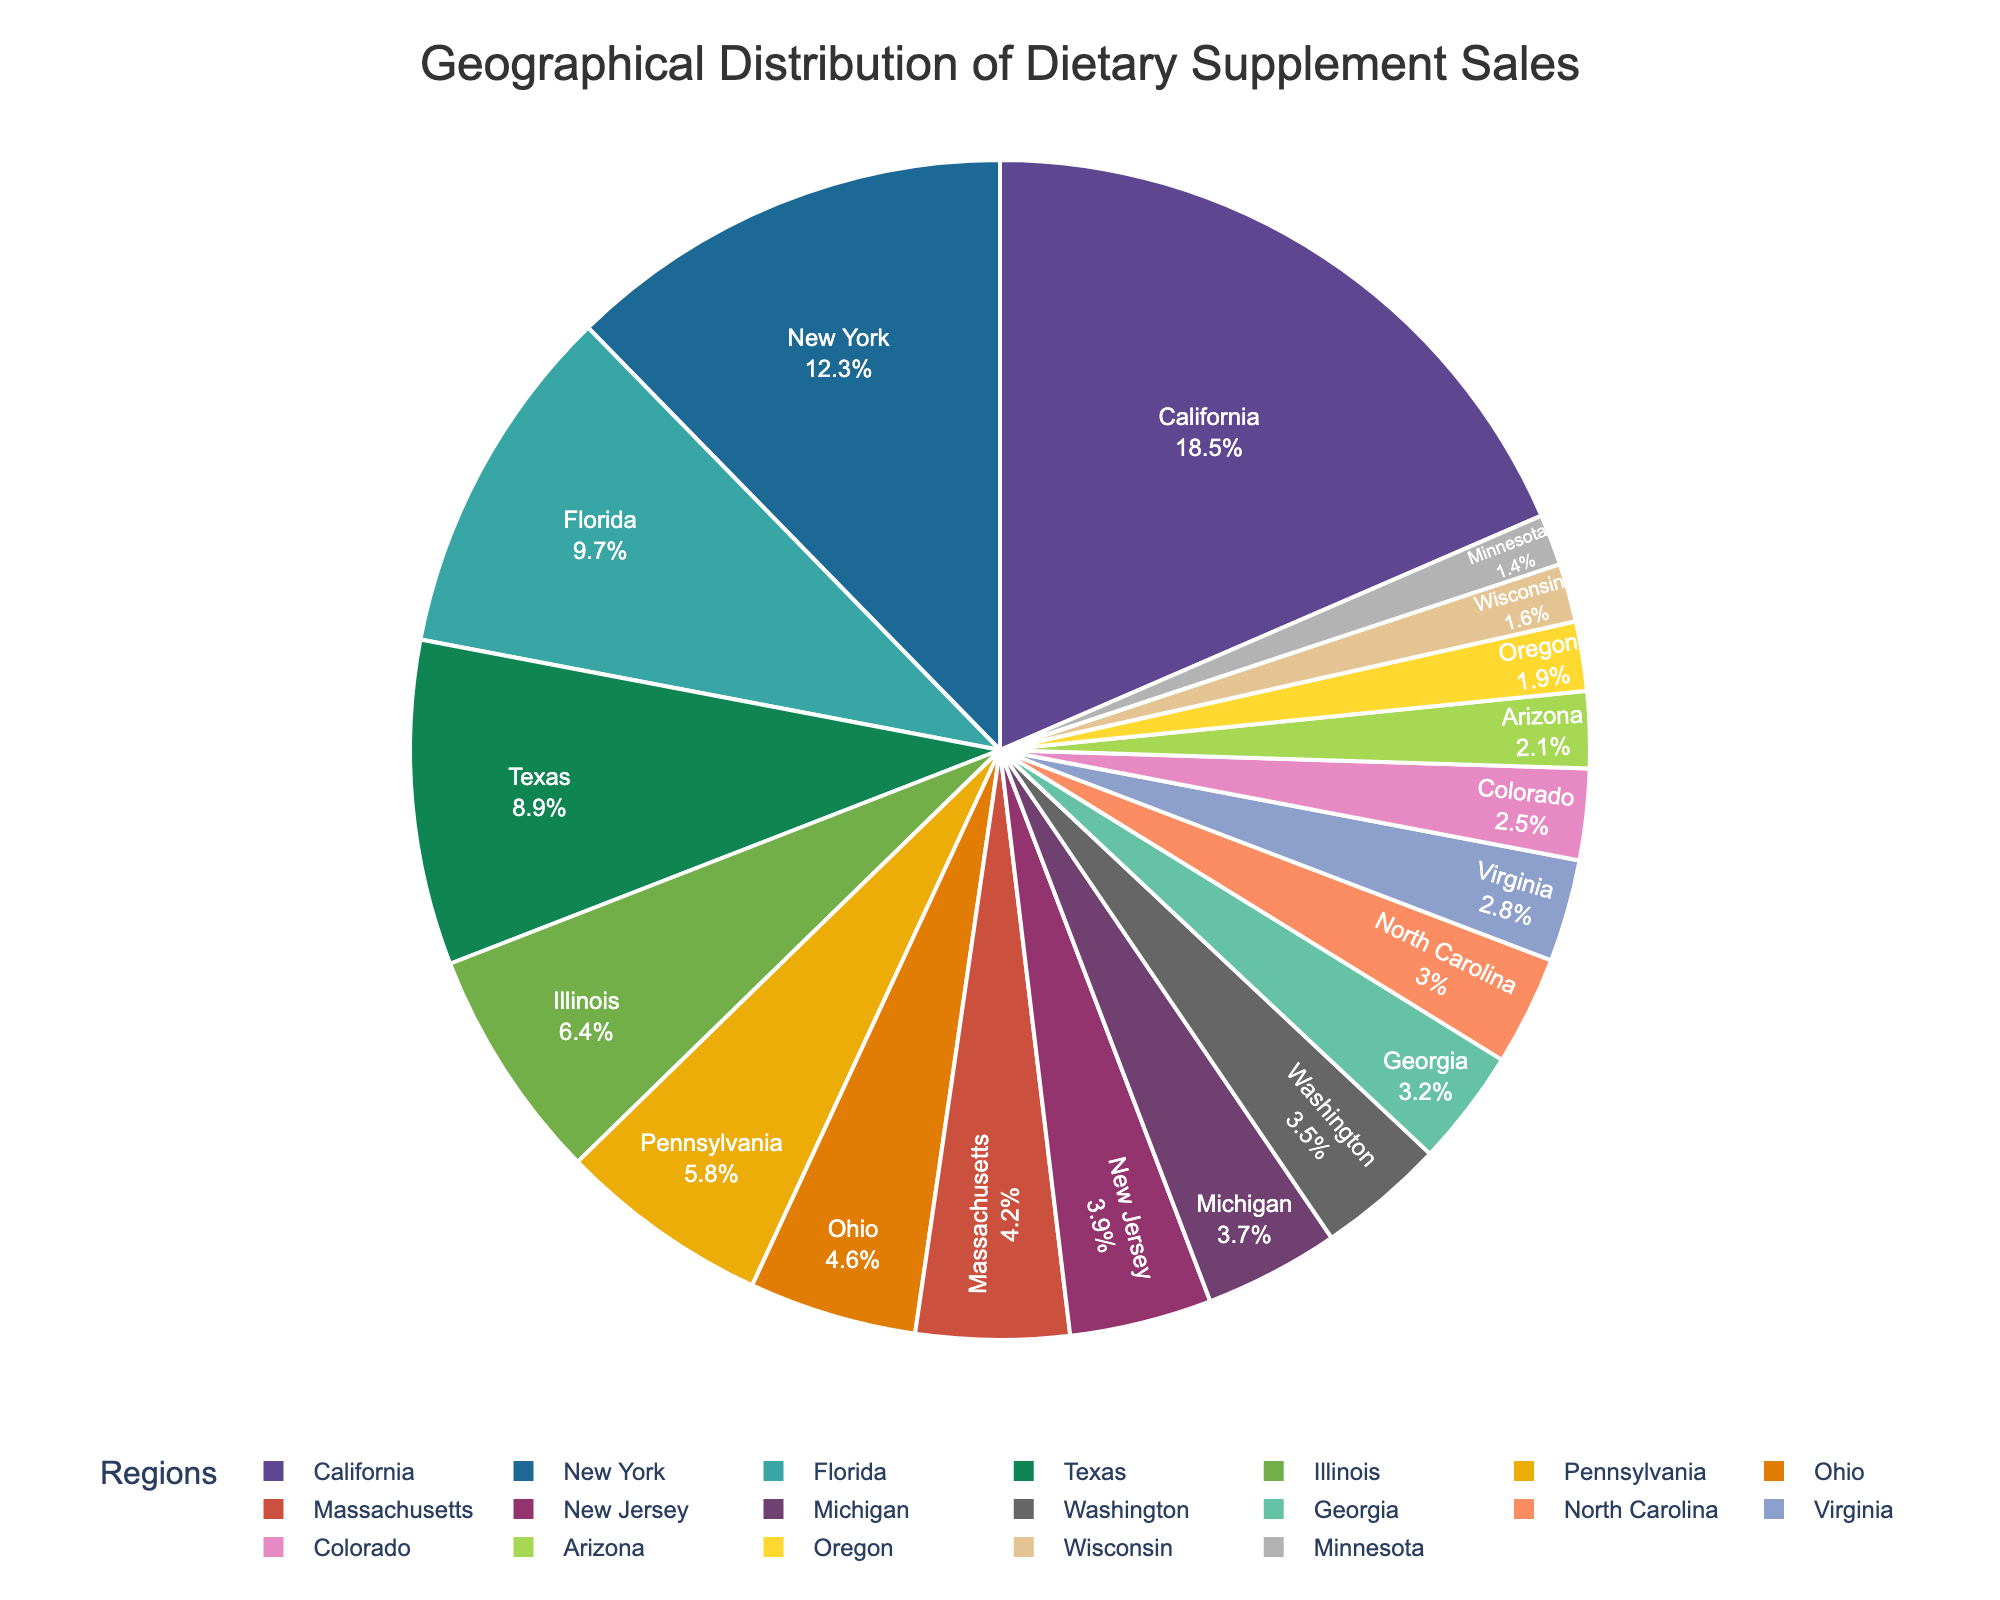Which region has the highest percentage of dietary supplement sales? California has the highest percentage of dietary supplement sales.
Answer: California Which regions have dietary supplement sales percentages greater than 10%? The regions with sales percentages greater than 10% are California (18.5%) and New York (12.3%).
Answer: California and New York How much higher is the sales percentage in Florida compared to Virginia? Florida has a sales percentage of 9.7%, and Virginia has 2.8%. The difference is 9.7% - 2.8% = 6.9%.
Answer: 6.9% Which three regions have the lowest percentages of dietary supplement sales? The three regions with the lowest percentages are Minnesota (1.4%), Wisconsin (1.6%), and Oregon (1.9%).
Answer: Minnesota, Wisconsin, Oregon What is the total sales percentage for the top five regions? The top five regions are California (18.5%), New York (12.3%), Florida (9.7%), Texas (8.9%), and Illinois (6.4%). Summing these gives 18.5 + 12.3 + 9.7 + 8.9 + 6.4 = 55.8%.
Answer: 55.8% Compare the sales percentage of Michigan and Washington. Which is higher? Michigan has a sales percentage of 3.7%, while Washington has 3.5%. Therefore, Michigan's percentage is slightly higher.
Answer: Michigan What is the average sales percentage of the regions listed? To find the average, you add up all the percentages and divide by the number of regions. The total sum of the percentages is 100%. There are 19 regions. So, the average is 100% / 19 ≈ 5.26%.
Answer: 5.26% Which regions have nearly equal sales percentages around 4%? Massachusetts (4.2%), New Jersey (3.9%), and Michigan (3.7%) have sales percentages around 4%.
Answer: Massachusetts, New Jersey, Michigan What is the combined sales percentage of Ohio, Massachusetts, and New Jersey? Ohio has 4.6%, Massachusetts has 4.2%, and New Jersey has 3.9%. The combined sales percentage is 4.6 + 4.2 + 3.9 = 12.7%.
Answer: 12.7% How does the sales percentage in Texas compare with that in Illinois? Texas has a sales percentage of 8.9%, while Illinois has 6.4%. Texas has a higher sales percentage by 8.9% - 6.4% = 2.5%.
Answer: Texas is higher by 2.5% 